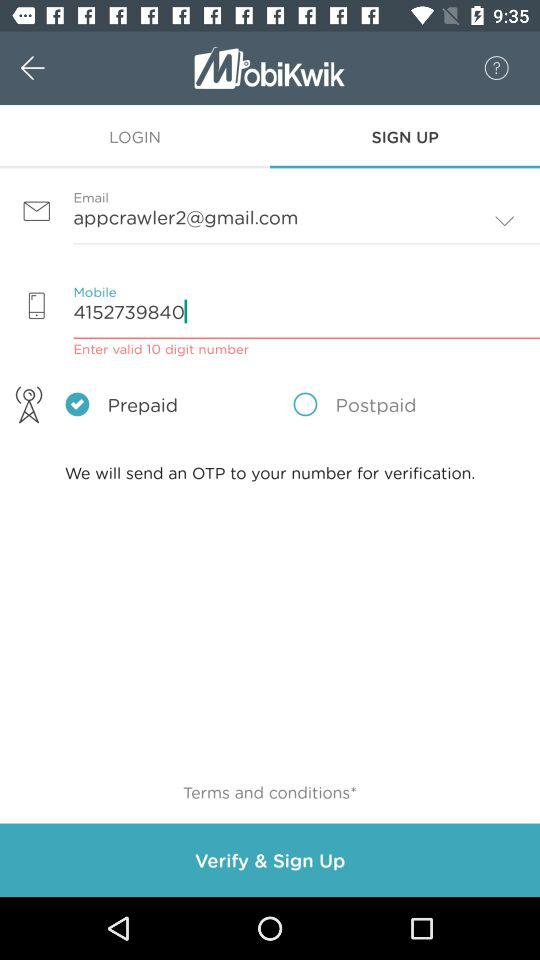How many text inputs are required to sign up?
Answer the question using a single word or phrase. 2 